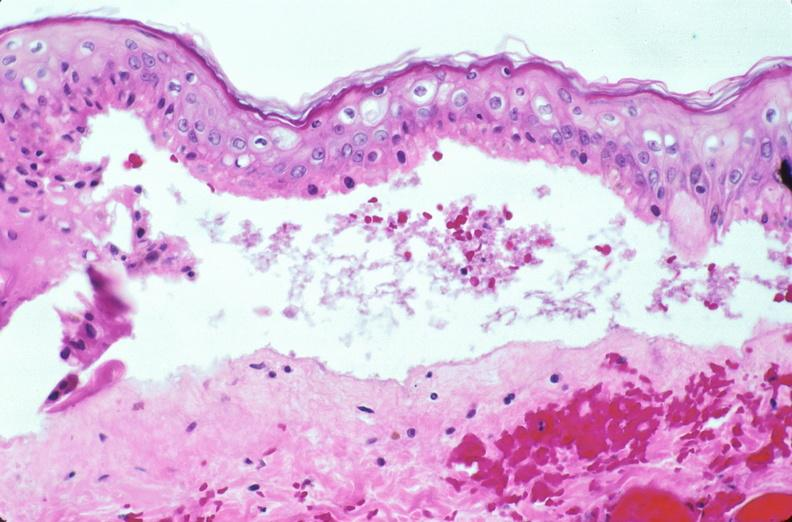does this image show skin, epidermolysis bullosa?
Answer the question using a single word or phrase. Yes 